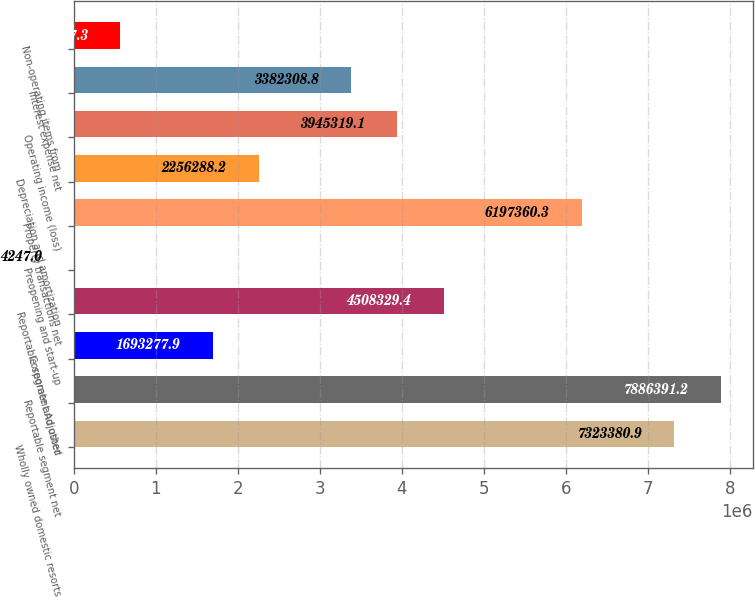Convert chart to OTSL. <chart><loc_0><loc_0><loc_500><loc_500><bar_chart><fcel>Wholly owned domestic resorts<fcel>Reportable segment net<fcel>Corporate and other<fcel>Reportable segment Adjusted<fcel>Preopening and start-up<fcel>Property transactions net<fcel>Depreciation and amortization<fcel>Operating income (loss)<fcel>Interest expense net<fcel>Non-operating items from<nl><fcel>7.32338e+06<fcel>7.88639e+06<fcel>1.69328e+06<fcel>4.50833e+06<fcel>4247<fcel>6.19736e+06<fcel>2.25629e+06<fcel>3.94532e+06<fcel>3.38231e+06<fcel>567257<nl></chart> 